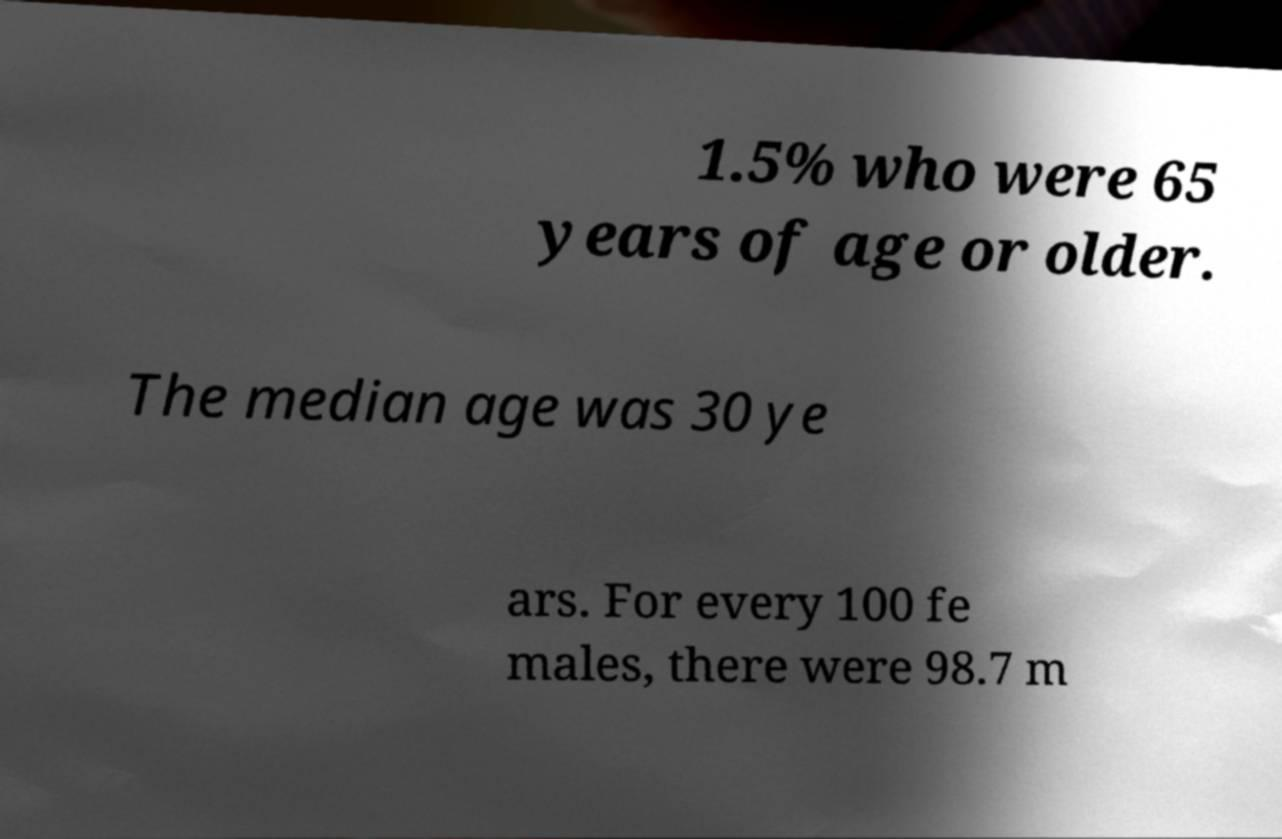Could you extract and type out the text from this image? 1.5% who were 65 years of age or older. The median age was 30 ye ars. For every 100 fe males, there were 98.7 m 